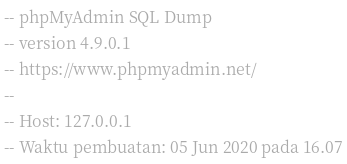Convert code to text. <code><loc_0><loc_0><loc_500><loc_500><_SQL_>-- phpMyAdmin SQL Dump
-- version 4.9.0.1
-- https://www.phpmyadmin.net/
--
-- Host: 127.0.0.1
-- Waktu pembuatan: 05 Jun 2020 pada 16.07</code> 